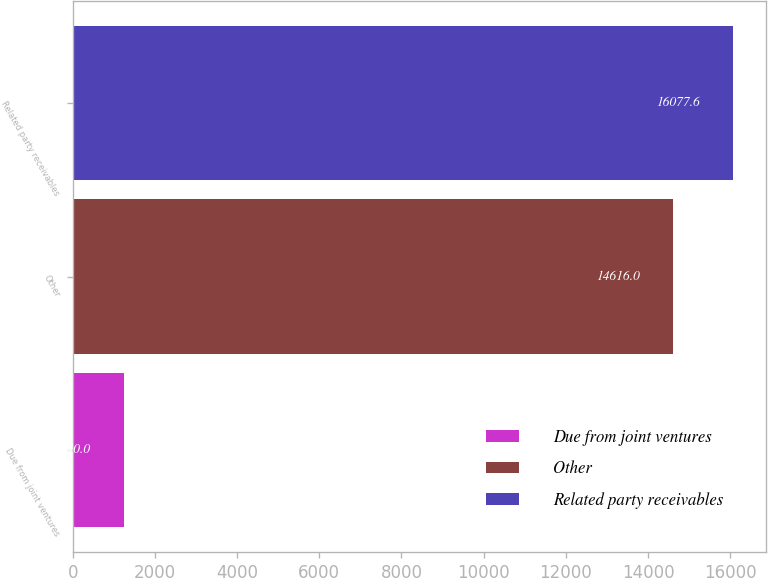Convert chart. <chart><loc_0><loc_0><loc_500><loc_500><bar_chart><fcel>Due from joint ventures<fcel>Other<fcel>Related party receivables<nl><fcel>1240<fcel>14616<fcel>16077.6<nl></chart> 